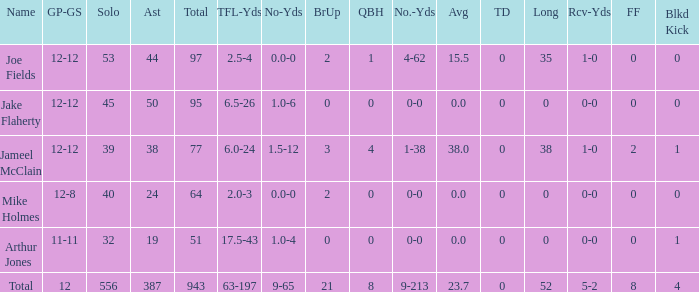How many tackle assists for the athlete who averages 2 387.0. 